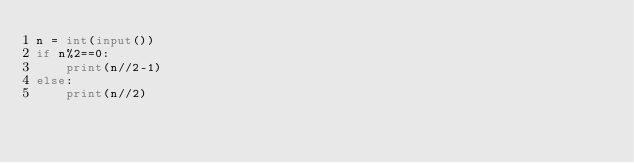Convert code to text. <code><loc_0><loc_0><loc_500><loc_500><_Python_>n = int(input())
if n%2==0:
    print(n//2-1)
else:
    print(n//2)</code> 